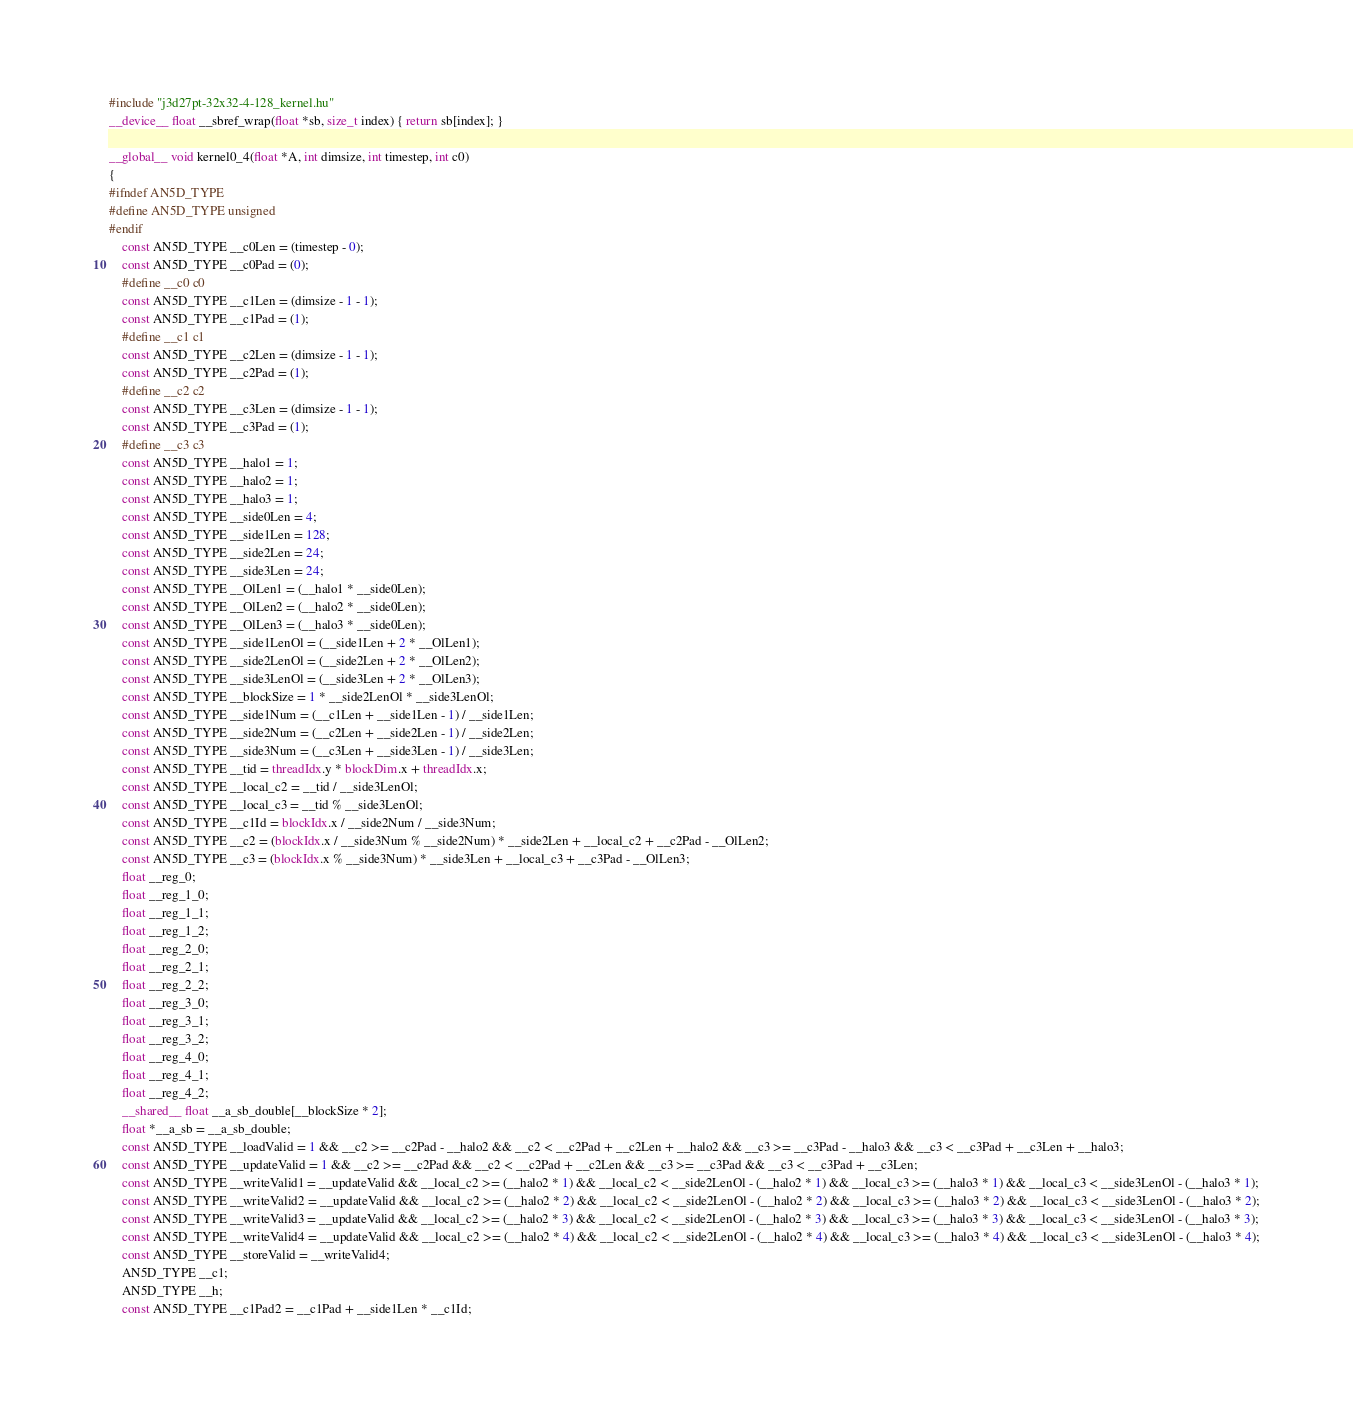Convert code to text. <code><loc_0><loc_0><loc_500><loc_500><_Cuda_>#include "j3d27pt-32x32-4-128_kernel.hu"
__device__ float __sbref_wrap(float *sb, size_t index) { return sb[index]; }

__global__ void kernel0_4(float *A, int dimsize, int timestep, int c0)
{
#ifndef AN5D_TYPE
#define AN5D_TYPE unsigned
#endif
    const AN5D_TYPE __c0Len = (timestep - 0);
    const AN5D_TYPE __c0Pad = (0);
    #define __c0 c0
    const AN5D_TYPE __c1Len = (dimsize - 1 - 1);
    const AN5D_TYPE __c1Pad = (1);
    #define __c1 c1
    const AN5D_TYPE __c2Len = (dimsize - 1 - 1);
    const AN5D_TYPE __c2Pad = (1);
    #define __c2 c2
    const AN5D_TYPE __c3Len = (dimsize - 1 - 1);
    const AN5D_TYPE __c3Pad = (1);
    #define __c3 c3
    const AN5D_TYPE __halo1 = 1;
    const AN5D_TYPE __halo2 = 1;
    const AN5D_TYPE __halo3 = 1;
    const AN5D_TYPE __side0Len = 4;
    const AN5D_TYPE __side1Len = 128;
    const AN5D_TYPE __side2Len = 24;
    const AN5D_TYPE __side3Len = 24;
    const AN5D_TYPE __OlLen1 = (__halo1 * __side0Len);
    const AN5D_TYPE __OlLen2 = (__halo2 * __side0Len);
    const AN5D_TYPE __OlLen3 = (__halo3 * __side0Len);
    const AN5D_TYPE __side1LenOl = (__side1Len + 2 * __OlLen1);
    const AN5D_TYPE __side2LenOl = (__side2Len + 2 * __OlLen2);
    const AN5D_TYPE __side3LenOl = (__side3Len + 2 * __OlLen3);
    const AN5D_TYPE __blockSize = 1 * __side2LenOl * __side3LenOl;
    const AN5D_TYPE __side1Num = (__c1Len + __side1Len - 1) / __side1Len;
    const AN5D_TYPE __side2Num = (__c2Len + __side2Len - 1) / __side2Len;
    const AN5D_TYPE __side3Num = (__c3Len + __side3Len - 1) / __side3Len;
    const AN5D_TYPE __tid = threadIdx.y * blockDim.x + threadIdx.x;
    const AN5D_TYPE __local_c2 = __tid / __side3LenOl;
    const AN5D_TYPE __local_c3 = __tid % __side3LenOl;
    const AN5D_TYPE __c1Id = blockIdx.x / __side2Num / __side3Num;
    const AN5D_TYPE __c2 = (blockIdx.x / __side3Num % __side2Num) * __side2Len + __local_c2 + __c2Pad - __OlLen2;
    const AN5D_TYPE __c3 = (blockIdx.x % __side3Num) * __side3Len + __local_c3 + __c3Pad - __OlLen3;
    float __reg_0;
    float __reg_1_0;
    float __reg_1_1;
    float __reg_1_2;
    float __reg_2_0;
    float __reg_2_1;
    float __reg_2_2;
    float __reg_3_0;
    float __reg_3_1;
    float __reg_3_2;
    float __reg_4_0;
    float __reg_4_1;
    float __reg_4_2;
    __shared__ float __a_sb_double[__blockSize * 2];
    float *__a_sb = __a_sb_double;
    const AN5D_TYPE __loadValid = 1 && __c2 >= __c2Pad - __halo2 && __c2 < __c2Pad + __c2Len + __halo2 && __c3 >= __c3Pad - __halo3 && __c3 < __c3Pad + __c3Len + __halo3;
    const AN5D_TYPE __updateValid = 1 && __c2 >= __c2Pad && __c2 < __c2Pad + __c2Len && __c3 >= __c3Pad && __c3 < __c3Pad + __c3Len;
    const AN5D_TYPE __writeValid1 = __updateValid && __local_c2 >= (__halo2 * 1) && __local_c2 < __side2LenOl - (__halo2 * 1) && __local_c3 >= (__halo3 * 1) && __local_c3 < __side3LenOl - (__halo3 * 1);
    const AN5D_TYPE __writeValid2 = __updateValid && __local_c2 >= (__halo2 * 2) && __local_c2 < __side2LenOl - (__halo2 * 2) && __local_c3 >= (__halo3 * 2) && __local_c3 < __side3LenOl - (__halo3 * 2);
    const AN5D_TYPE __writeValid3 = __updateValid && __local_c2 >= (__halo2 * 3) && __local_c2 < __side2LenOl - (__halo2 * 3) && __local_c3 >= (__halo3 * 3) && __local_c3 < __side3LenOl - (__halo3 * 3);
    const AN5D_TYPE __writeValid4 = __updateValid && __local_c2 >= (__halo2 * 4) && __local_c2 < __side2LenOl - (__halo2 * 4) && __local_c3 >= (__halo3 * 4) && __local_c3 < __side3LenOl - (__halo3 * 4);
    const AN5D_TYPE __storeValid = __writeValid4;
    AN5D_TYPE __c1;
    AN5D_TYPE __h;
    const AN5D_TYPE __c1Pad2 = __c1Pad + __side1Len * __c1Id;</code> 